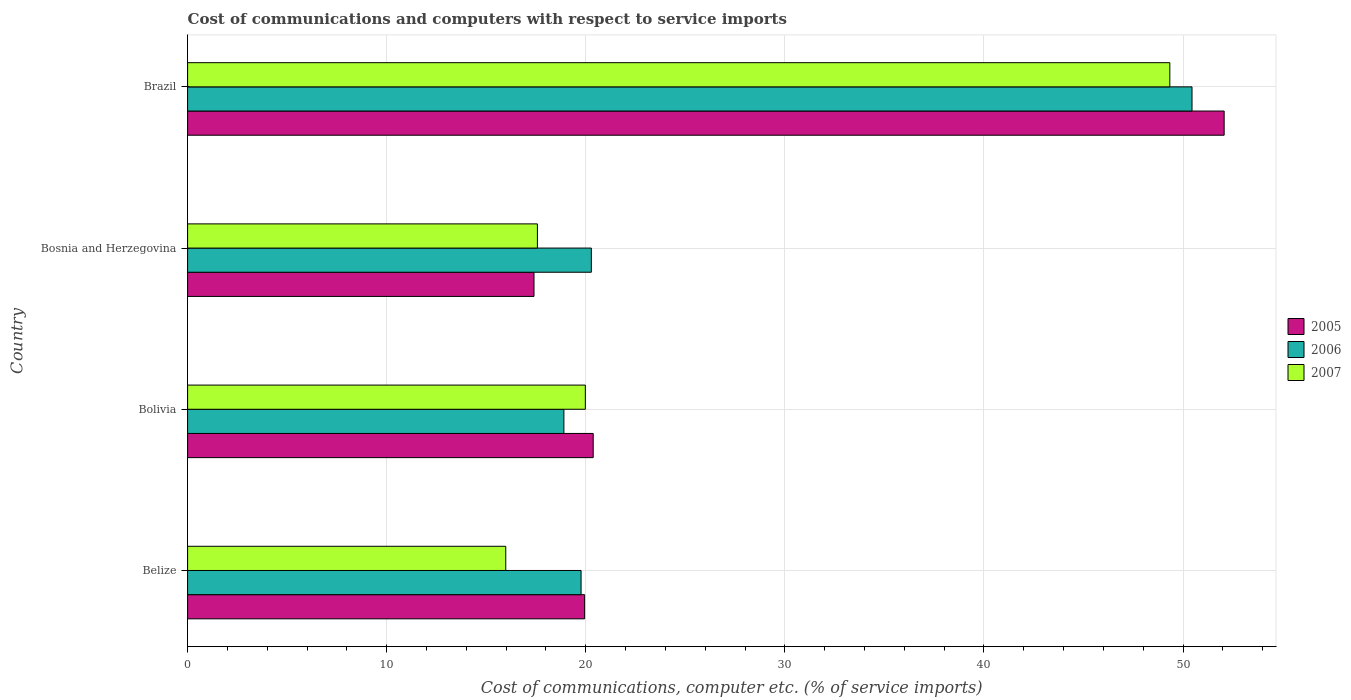Are the number of bars per tick equal to the number of legend labels?
Provide a succinct answer. Yes. Are the number of bars on each tick of the Y-axis equal?
Offer a very short reply. Yes. How many bars are there on the 3rd tick from the bottom?
Your answer should be compact. 3. What is the label of the 4th group of bars from the top?
Give a very brief answer. Belize. In how many cases, is the number of bars for a given country not equal to the number of legend labels?
Make the answer very short. 0. What is the cost of communications and computers in 2007 in Bosnia and Herzegovina?
Provide a succinct answer. 17.57. Across all countries, what is the maximum cost of communications and computers in 2005?
Keep it short and to the point. 52.06. Across all countries, what is the minimum cost of communications and computers in 2005?
Offer a very short reply. 17.4. In which country was the cost of communications and computers in 2007 minimum?
Your response must be concise. Belize. What is the total cost of communications and computers in 2007 in the graph?
Your answer should be compact. 102.86. What is the difference between the cost of communications and computers in 2005 in Bolivia and that in Brazil?
Make the answer very short. -31.69. What is the difference between the cost of communications and computers in 2005 in Bolivia and the cost of communications and computers in 2006 in Brazil?
Keep it short and to the point. -30.08. What is the average cost of communications and computers in 2005 per country?
Provide a short and direct response. 27.44. What is the difference between the cost of communications and computers in 2005 and cost of communications and computers in 2007 in Belize?
Ensure brevity in your answer.  3.96. In how many countries, is the cost of communications and computers in 2007 greater than 42 %?
Make the answer very short. 1. What is the ratio of the cost of communications and computers in 2007 in Bolivia to that in Bosnia and Herzegovina?
Keep it short and to the point. 1.14. Is the difference between the cost of communications and computers in 2005 in Belize and Brazil greater than the difference between the cost of communications and computers in 2007 in Belize and Brazil?
Make the answer very short. Yes. What is the difference between the highest and the second highest cost of communications and computers in 2006?
Offer a very short reply. 30.17. What is the difference between the highest and the lowest cost of communications and computers in 2007?
Provide a succinct answer. 33.35. Is the sum of the cost of communications and computers in 2005 in Bolivia and Bosnia and Herzegovina greater than the maximum cost of communications and computers in 2006 across all countries?
Your answer should be compact. No. What does the 1st bar from the top in Bolivia represents?
Your response must be concise. 2007. What does the 3rd bar from the bottom in Belize represents?
Offer a very short reply. 2007. Is it the case that in every country, the sum of the cost of communications and computers in 2006 and cost of communications and computers in 2005 is greater than the cost of communications and computers in 2007?
Make the answer very short. Yes. How many bars are there?
Make the answer very short. 12. Are all the bars in the graph horizontal?
Your response must be concise. Yes. What is the difference between two consecutive major ticks on the X-axis?
Keep it short and to the point. 10. Are the values on the major ticks of X-axis written in scientific E-notation?
Offer a terse response. No. Does the graph contain any zero values?
Make the answer very short. No. Does the graph contain grids?
Ensure brevity in your answer.  Yes. Where does the legend appear in the graph?
Offer a terse response. Center right. How many legend labels are there?
Provide a short and direct response. 3. How are the legend labels stacked?
Keep it short and to the point. Vertical. What is the title of the graph?
Provide a succinct answer. Cost of communications and computers with respect to service imports. Does "1971" appear as one of the legend labels in the graph?
Your response must be concise. No. What is the label or title of the X-axis?
Offer a very short reply. Cost of communications, computer etc. (% of service imports). What is the Cost of communications, computer etc. (% of service imports) in 2005 in Belize?
Your answer should be compact. 19.94. What is the Cost of communications, computer etc. (% of service imports) in 2006 in Belize?
Provide a succinct answer. 19.76. What is the Cost of communications, computer etc. (% of service imports) in 2007 in Belize?
Provide a succinct answer. 15.98. What is the Cost of communications, computer etc. (% of service imports) in 2005 in Bolivia?
Make the answer very short. 20.37. What is the Cost of communications, computer etc. (% of service imports) of 2006 in Bolivia?
Your answer should be very brief. 18.9. What is the Cost of communications, computer etc. (% of service imports) of 2007 in Bolivia?
Your response must be concise. 19.98. What is the Cost of communications, computer etc. (% of service imports) of 2005 in Bosnia and Herzegovina?
Your response must be concise. 17.4. What is the Cost of communications, computer etc. (% of service imports) of 2006 in Bosnia and Herzegovina?
Your response must be concise. 20.28. What is the Cost of communications, computer etc. (% of service imports) of 2007 in Bosnia and Herzegovina?
Ensure brevity in your answer.  17.57. What is the Cost of communications, computer etc. (% of service imports) of 2005 in Brazil?
Offer a very short reply. 52.06. What is the Cost of communications, computer etc. (% of service imports) of 2006 in Brazil?
Ensure brevity in your answer.  50.45. What is the Cost of communications, computer etc. (% of service imports) of 2007 in Brazil?
Give a very brief answer. 49.34. Across all countries, what is the maximum Cost of communications, computer etc. (% of service imports) of 2005?
Your answer should be very brief. 52.06. Across all countries, what is the maximum Cost of communications, computer etc. (% of service imports) of 2006?
Your answer should be compact. 50.45. Across all countries, what is the maximum Cost of communications, computer etc. (% of service imports) in 2007?
Offer a terse response. 49.34. Across all countries, what is the minimum Cost of communications, computer etc. (% of service imports) in 2005?
Your answer should be compact. 17.4. Across all countries, what is the minimum Cost of communications, computer etc. (% of service imports) in 2006?
Your response must be concise. 18.9. Across all countries, what is the minimum Cost of communications, computer etc. (% of service imports) in 2007?
Keep it short and to the point. 15.98. What is the total Cost of communications, computer etc. (% of service imports) in 2005 in the graph?
Keep it short and to the point. 109.78. What is the total Cost of communications, computer etc. (% of service imports) of 2006 in the graph?
Give a very brief answer. 109.39. What is the total Cost of communications, computer etc. (% of service imports) in 2007 in the graph?
Give a very brief answer. 102.86. What is the difference between the Cost of communications, computer etc. (% of service imports) in 2005 in Belize and that in Bolivia?
Ensure brevity in your answer.  -0.43. What is the difference between the Cost of communications, computer etc. (% of service imports) in 2006 in Belize and that in Bolivia?
Give a very brief answer. 0.86. What is the difference between the Cost of communications, computer etc. (% of service imports) of 2007 in Belize and that in Bolivia?
Offer a very short reply. -4. What is the difference between the Cost of communications, computer etc. (% of service imports) of 2005 in Belize and that in Bosnia and Herzegovina?
Your answer should be compact. 2.54. What is the difference between the Cost of communications, computer etc. (% of service imports) in 2006 in Belize and that in Bosnia and Herzegovina?
Offer a terse response. -0.52. What is the difference between the Cost of communications, computer etc. (% of service imports) of 2007 in Belize and that in Bosnia and Herzegovina?
Provide a short and direct response. -1.59. What is the difference between the Cost of communications, computer etc. (% of service imports) in 2005 in Belize and that in Brazil?
Give a very brief answer. -32.12. What is the difference between the Cost of communications, computer etc. (% of service imports) of 2006 in Belize and that in Brazil?
Your answer should be compact. -30.69. What is the difference between the Cost of communications, computer etc. (% of service imports) of 2007 in Belize and that in Brazil?
Offer a terse response. -33.35. What is the difference between the Cost of communications, computer etc. (% of service imports) of 2005 in Bolivia and that in Bosnia and Herzegovina?
Offer a terse response. 2.97. What is the difference between the Cost of communications, computer etc. (% of service imports) of 2006 in Bolivia and that in Bosnia and Herzegovina?
Offer a very short reply. -1.38. What is the difference between the Cost of communications, computer etc. (% of service imports) of 2007 in Bolivia and that in Bosnia and Herzegovina?
Offer a terse response. 2.41. What is the difference between the Cost of communications, computer etc. (% of service imports) in 2005 in Bolivia and that in Brazil?
Provide a short and direct response. -31.69. What is the difference between the Cost of communications, computer etc. (% of service imports) of 2006 in Bolivia and that in Brazil?
Provide a short and direct response. -31.55. What is the difference between the Cost of communications, computer etc. (% of service imports) of 2007 in Bolivia and that in Brazil?
Offer a terse response. -29.36. What is the difference between the Cost of communications, computer etc. (% of service imports) of 2005 in Bosnia and Herzegovina and that in Brazil?
Your answer should be compact. -34.67. What is the difference between the Cost of communications, computer etc. (% of service imports) in 2006 in Bosnia and Herzegovina and that in Brazil?
Your answer should be very brief. -30.17. What is the difference between the Cost of communications, computer etc. (% of service imports) of 2007 in Bosnia and Herzegovina and that in Brazil?
Your response must be concise. -31.77. What is the difference between the Cost of communications, computer etc. (% of service imports) of 2005 in Belize and the Cost of communications, computer etc. (% of service imports) of 2006 in Bolivia?
Your response must be concise. 1.04. What is the difference between the Cost of communications, computer etc. (% of service imports) in 2005 in Belize and the Cost of communications, computer etc. (% of service imports) in 2007 in Bolivia?
Provide a succinct answer. -0.04. What is the difference between the Cost of communications, computer etc. (% of service imports) in 2006 in Belize and the Cost of communications, computer etc. (% of service imports) in 2007 in Bolivia?
Provide a succinct answer. -0.21. What is the difference between the Cost of communications, computer etc. (% of service imports) of 2005 in Belize and the Cost of communications, computer etc. (% of service imports) of 2006 in Bosnia and Herzegovina?
Make the answer very short. -0.34. What is the difference between the Cost of communications, computer etc. (% of service imports) in 2005 in Belize and the Cost of communications, computer etc. (% of service imports) in 2007 in Bosnia and Herzegovina?
Give a very brief answer. 2.37. What is the difference between the Cost of communications, computer etc. (% of service imports) of 2006 in Belize and the Cost of communications, computer etc. (% of service imports) of 2007 in Bosnia and Herzegovina?
Keep it short and to the point. 2.19. What is the difference between the Cost of communications, computer etc. (% of service imports) of 2005 in Belize and the Cost of communications, computer etc. (% of service imports) of 2006 in Brazil?
Keep it short and to the point. -30.51. What is the difference between the Cost of communications, computer etc. (% of service imports) in 2005 in Belize and the Cost of communications, computer etc. (% of service imports) in 2007 in Brazil?
Your answer should be compact. -29.39. What is the difference between the Cost of communications, computer etc. (% of service imports) of 2006 in Belize and the Cost of communications, computer etc. (% of service imports) of 2007 in Brazil?
Give a very brief answer. -29.57. What is the difference between the Cost of communications, computer etc. (% of service imports) in 2005 in Bolivia and the Cost of communications, computer etc. (% of service imports) in 2006 in Bosnia and Herzegovina?
Your answer should be very brief. 0.09. What is the difference between the Cost of communications, computer etc. (% of service imports) of 2005 in Bolivia and the Cost of communications, computer etc. (% of service imports) of 2007 in Bosnia and Herzegovina?
Offer a very short reply. 2.8. What is the difference between the Cost of communications, computer etc. (% of service imports) in 2006 in Bolivia and the Cost of communications, computer etc. (% of service imports) in 2007 in Bosnia and Herzegovina?
Offer a terse response. 1.33. What is the difference between the Cost of communications, computer etc. (% of service imports) of 2005 in Bolivia and the Cost of communications, computer etc. (% of service imports) of 2006 in Brazil?
Provide a short and direct response. -30.08. What is the difference between the Cost of communications, computer etc. (% of service imports) of 2005 in Bolivia and the Cost of communications, computer etc. (% of service imports) of 2007 in Brazil?
Offer a terse response. -28.96. What is the difference between the Cost of communications, computer etc. (% of service imports) in 2006 in Bolivia and the Cost of communications, computer etc. (% of service imports) in 2007 in Brazil?
Your response must be concise. -30.43. What is the difference between the Cost of communications, computer etc. (% of service imports) in 2005 in Bosnia and Herzegovina and the Cost of communications, computer etc. (% of service imports) in 2006 in Brazil?
Your answer should be very brief. -33.05. What is the difference between the Cost of communications, computer etc. (% of service imports) of 2005 in Bosnia and Herzegovina and the Cost of communications, computer etc. (% of service imports) of 2007 in Brazil?
Ensure brevity in your answer.  -31.94. What is the difference between the Cost of communications, computer etc. (% of service imports) in 2006 in Bosnia and Herzegovina and the Cost of communications, computer etc. (% of service imports) in 2007 in Brazil?
Make the answer very short. -29.06. What is the average Cost of communications, computer etc. (% of service imports) in 2005 per country?
Give a very brief answer. 27.44. What is the average Cost of communications, computer etc. (% of service imports) of 2006 per country?
Your answer should be compact. 27.35. What is the average Cost of communications, computer etc. (% of service imports) of 2007 per country?
Keep it short and to the point. 25.72. What is the difference between the Cost of communications, computer etc. (% of service imports) in 2005 and Cost of communications, computer etc. (% of service imports) in 2006 in Belize?
Ensure brevity in your answer.  0.18. What is the difference between the Cost of communications, computer etc. (% of service imports) of 2005 and Cost of communications, computer etc. (% of service imports) of 2007 in Belize?
Ensure brevity in your answer.  3.96. What is the difference between the Cost of communications, computer etc. (% of service imports) of 2006 and Cost of communications, computer etc. (% of service imports) of 2007 in Belize?
Make the answer very short. 3.78. What is the difference between the Cost of communications, computer etc. (% of service imports) of 2005 and Cost of communications, computer etc. (% of service imports) of 2006 in Bolivia?
Give a very brief answer. 1.47. What is the difference between the Cost of communications, computer etc. (% of service imports) in 2005 and Cost of communications, computer etc. (% of service imports) in 2007 in Bolivia?
Offer a very short reply. 0.39. What is the difference between the Cost of communications, computer etc. (% of service imports) in 2006 and Cost of communications, computer etc. (% of service imports) in 2007 in Bolivia?
Provide a short and direct response. -1.08. What is the difference between the Cost of communications, computer etc. (% of service imports) in 2005 and Cost of communications, computer etc. (% of service imports) in 2006 in Bosnia and Herzegovina?
Ensure brevity in your answer.  -2.88. What is the difference between the Cost of communications, computer etc. (% of service imports) in 2005 and Cost of communications, computer etc. (% of service imports) in 2007 in Bosnia and Herzegovina?
Provide a short and direct response. -0.17. What is the difference between the Cost of communications, computer etc. (% of service imports) in 2006 and Cost of communications, computer etc. (% of service imports) in 2007 in Bosnia and Herzegovina?
Keep it short and to the point. 2.71. What is the difference between the Cost of communications, computer etc. (% of service imports) of 2005 and Cost of communications, computer etc. (% of service imports) of 2006 in Brazil?
Make the answer very short. 1.61. What is the difference between the Cost of communications, computer etc. (% of service imports) of 2005 and Cost of communications, computer etc. (% of service imports) of 2007 in Brazil?
Keep it short and to the point. 2.73. What is the difference between the Cost of communications, computer etc. (% of service imports) of 2006 and Cost of communications, computer etc. (% of service imports) of 2007 in Brazil?
Provide a short and direct response. 1.11. What is the ratio of the Cost of communications, computer etc. (% of service imports) in 2005 in Belize to that in Bolivia?
Keep it short and to the point. 0.98. What is the ratio of the Cost of communications, computer etc. (% of service imports) in 2006 in Belize to that in Bolivia?
Ensure brevity in your answer.  1.05. What is the ratio of the Cost of communications, computer etc. (% of service imports) of 2007 in Belize to that in Bolivia?
Provide a short and direct response. 0.8. What is the ratio of the Cost of communications, computer etc. (% of service imports) in 2005 in Belize to that in Bosnia and Herzegovina?
Make the answer very short. 1.15. What is the ratio of the Cost of communications, computer etc. (% of service imports) in 2006 in Belize to that in Bosnia and Herzegovina?
Keep it short and to the point. 0.97. What is the ratio of the Cost of communications, computer etc. (% of service imports) in 2007 in Belize to that in Bosnia and Herzegovina?
Keep it short and to the point. 0.91. What is the ratio of the Cost of communications, computer etc. (% of service imports) in 2005 in Belize to that in Brazil?
Make the answer very short. 0.38. What is the ratio of the Cost of communications, computer etc. (% of service imports) in 2006 in Belize to that in Brazil?
Ensure brevity in your answer.  0.39. What is the ratio of the Cost of communications, computer etc. (% of service imports) of 2007 in Belize to that in Brazil?
Provide a succinct answer. 0.32. What is the ratio of the Cost of communications, computer etc. (% of service imports) in 2005 in Bolivia to that in Bosnia and Herzegovina?
Ensure brevity in your answer.  1.17. What is the ratio of the Cost of communications, computer etc. (% of service imports) of 2006 in Bolivia to that in Bosnia and Herzegovina?
Ensure brevity in your answer.  0.93. What is the ratio of the Cost of communications, computer etc. (% of service imports) in 2007 in Bolivia to that in Bosnia and Herzegovina?
Provide a succinct answer. 1.14. What is the ratio of the Cost of communications, computer etc. (% of service imports) in 2005 in Bolivia to that in Brazil?
Your answer should be very brief. 0.39. What is the ratio of the Cost of communications, computer etc. (% of service imports) in 2006 in Bolivia to that in Brazil?
Your answer should be very brief. 0.37. What is the ratio of the Cost of communications, computer etc. (% of service imports) of 2007 in Bolivia to that in Brazil?
Offer a very short reply. 0.4. What is the ratio of the Cost of communications, computer etc. (% of service imports) in 2005 in Bosnia and Herzegovina to that in Brazil?
Offer a terse response. 0.33. What is the ratio of the Cost of communications, computer etc. (% of service imports) in 2006 in Bosnia and Herzegovina to that in Brazil?
Provide a short and direct response. 0.4. What is the ratio of the Cost of communications, computer etc. (% of service imports) of 2007 in Bosnia and Herzegovina to that in Brazil?
Provide a succinct answer. 0.36. What is the difference between the highest and the second highest Cost of communications, computer etc. (% of service imports) of 2005?
Provide a succinct answer. 31.69. What is the difference between the highest and the second highest Cost of communications, computer etc. (% of service imports) in 2006?
Make the answer very short. 30.17. What is the difference between the highest and the second highest Cost of communications, computer etc. (% of service imports) of 2007?
Keep it short and to the point. 29.36. What is the difference between the highest and the lowest Cost of communications, computer etc. (% of service imports) of 2005?
Give a very brief answer. 34.67. What is the difference between the highest and the lowest Cost of communications, computer etc. (% of service imports) in 2006?
Provide a succinct answer. 31.55. What is the difference between the highest and the lowest Cost of communications, computer etc. (% of service imports) in 2007?
Offer a very short reply. 33.35. 